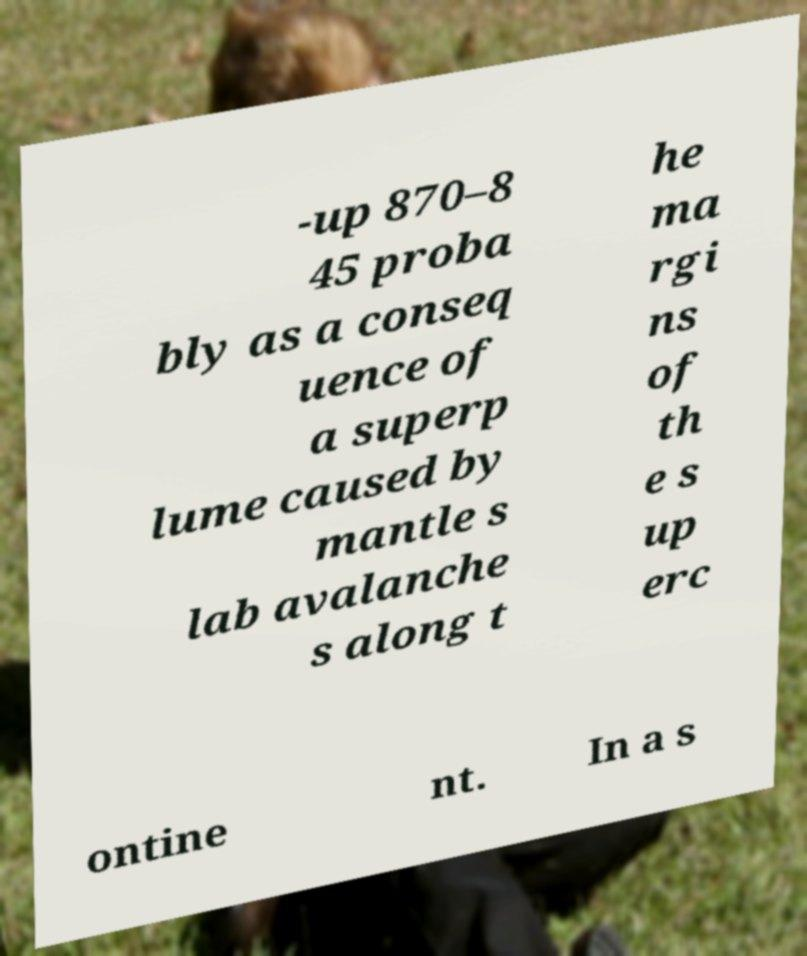Please identify and transcribe the text found in this image. -up 870–8 45 proba bly as a conseq uence of a superp lume caused by mantle s lab avalanche s along t he ma rgi ns of th e s up erc ontine nt. In a s 